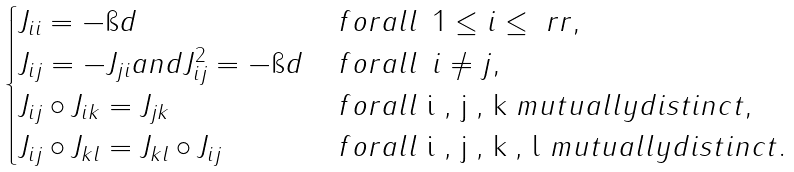Convert formula to latex. <formula><loc_0><loc_0><loc_500><loc_500>\begin{cases} J _ { i i } = - \i d \quad & \, f o r a l l \, \ 1 \leq i \leq \ r r , \\ J _ { i j } = - J _ { j i } a n d J _ { i j } ^ { 2 } = - \i d & \, f o r a l l \, \ i \ne j , \\ J _ { i j } \circ J _ { i k } = J _ { j k } & \, f o r a l l $ i , j , k $ m u t u a l l y d i s t i n c t , \\ J _ { i j } \circ J _ { k l } = J _ { k l } \circ J _ { i j } & \, f o r a l l $ i , j , k , l $ m u t u a l l y d i s t i n c t . \end{cases}</formula> 